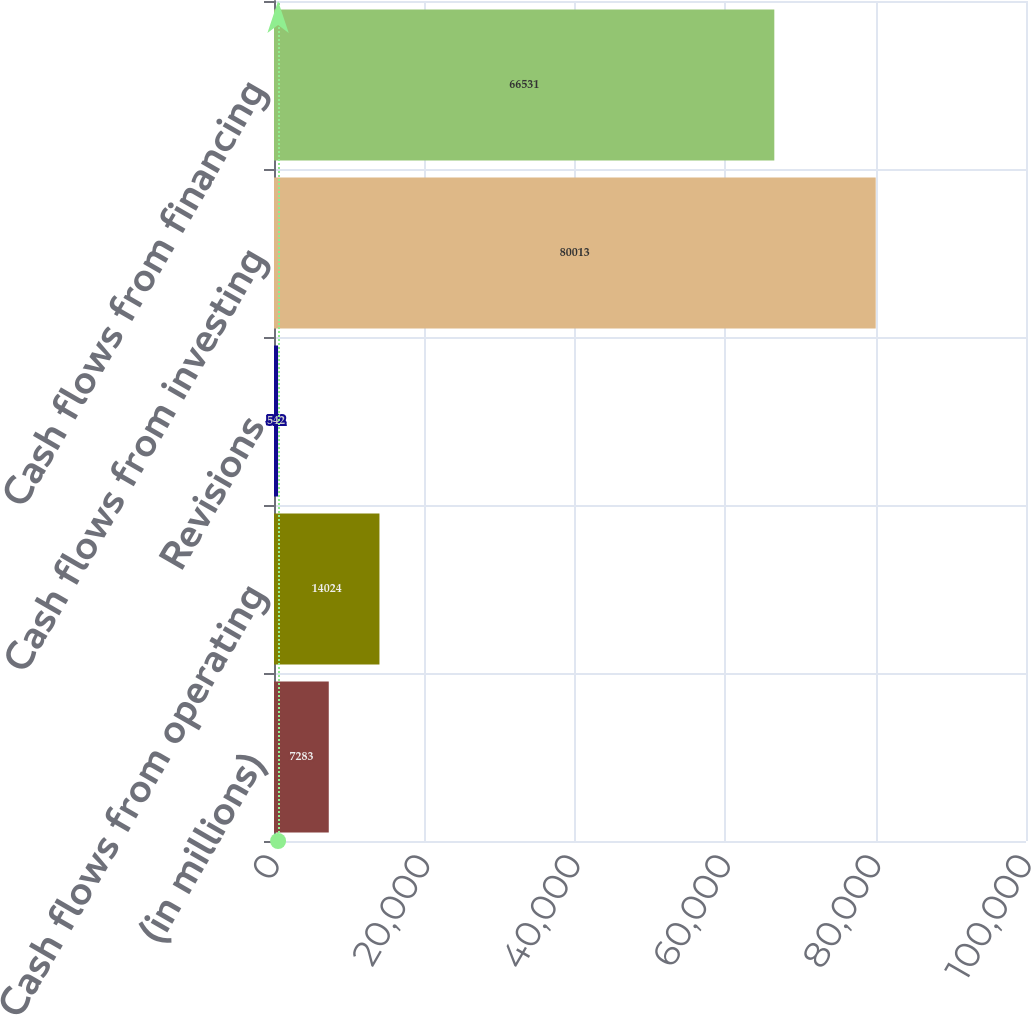Convert chart. <chart><loc_0><loc_0><loc_500><loc_500><bar_chart><fcel>(in millions)<fcel>Cash flows from operating<fcel>Revisions<fcel>Cash flows from investing<fcel>Cash flows from financing<nl><fcel>7283<fcel>14024<fcel>542<fcel>80013<fcel>66531<nl></chart> 